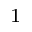Convert formula to latex. <formula><loc_0><loc_0><loc_500><loc_500>^ { 1 }</formula> 